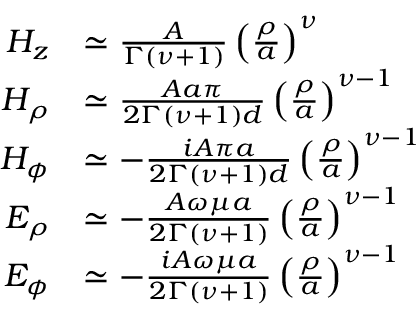Convert formula to latex. <formula><loc_0><loc_0><loc_500><loc_500>\begin{array} { r l } { H _ { z } } & { \simeq \frac { A } { \Gamma \left ( \nu + 1 \right ) } \left ( \frac { \rho } { a } \right ) ^ { \nu } } \\ { H _ { \rho } } & { \simeq \frac { A a \pi } { 2 \Gamma \left ( \nu + 1 \right ) d } \left ( \frac { \rho } { a } \right ) ^ { \nu - 1 } } \\ { H _ { \phi } } & { \simeq - \frac { i A \pi a } { 2 \Gamma ( \nu + 1 ) d } \left ( \frac { \rho } { a } \right ) ^ { \nu - 1 } } \\ { E _ { \rho } } & { \simeq - \frac { A \omega \mu a } { 2 \Gamma ( \nu + 1 ) } \left ( \frac { \rho } { a } \right ) ^ { \nu - 1 } } \\ { E _ { \phi } } & { \simeq - \frac { i A \omega \mu a } { 2 \Gamma ( \nu + 1 ) } \left ( \frac { \rho } { a } \right ) ^ { \nu - 1 } } \end{array}</formula> 